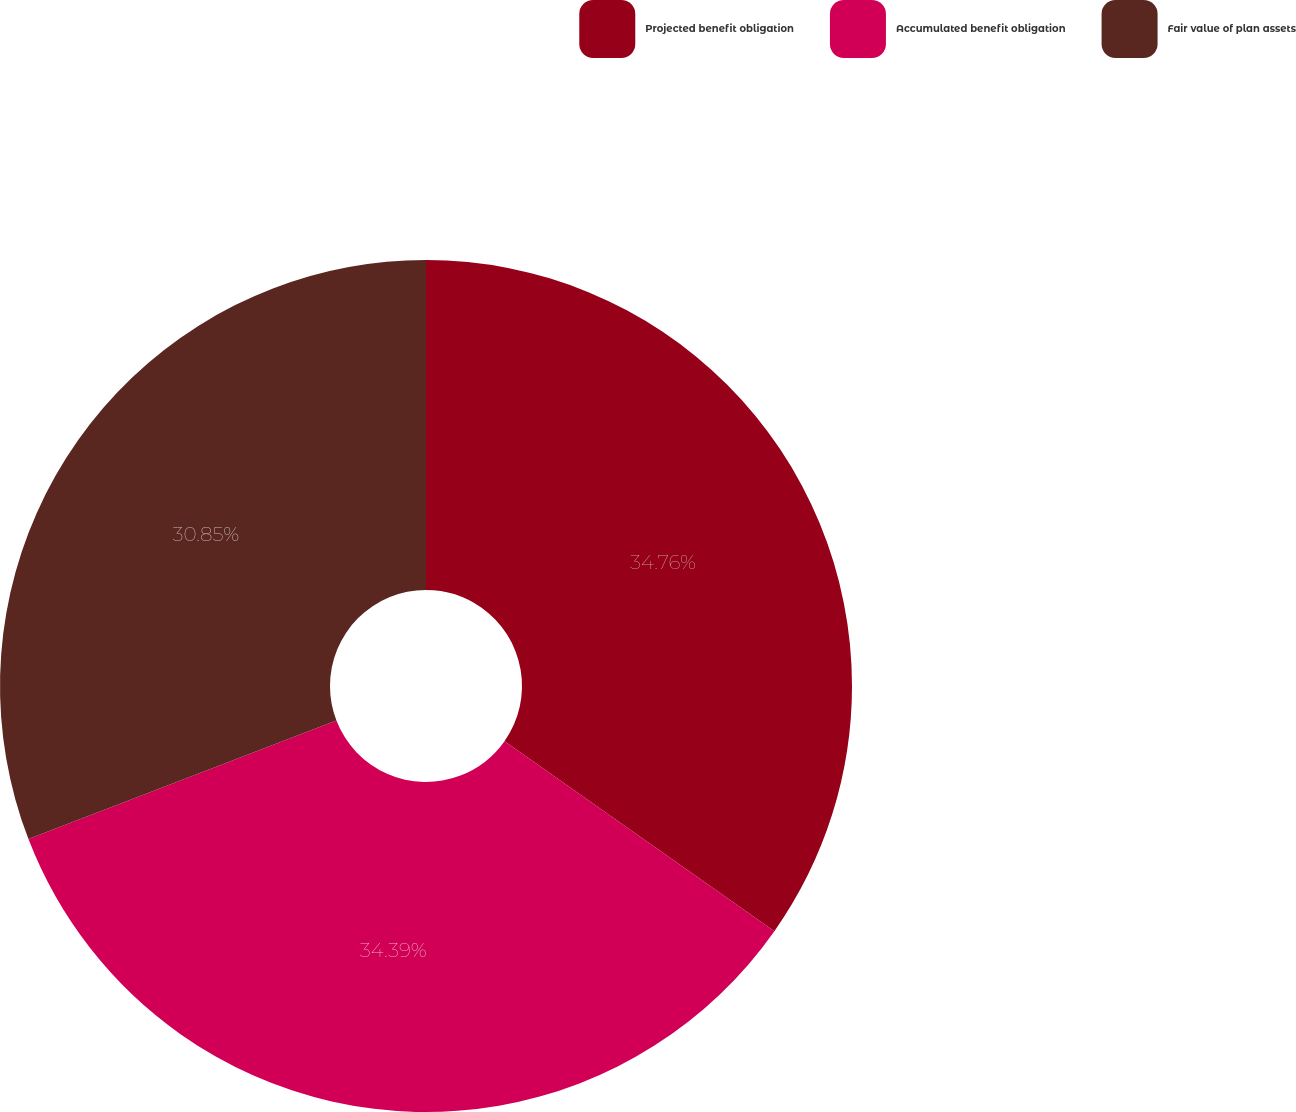<chart> <loc_0><loc_0><loc_500><loc_500><pie_chart><fcel>Projected benefit obligation<fcel>Accumulated benefit obligation<fcel>Fair value of plan assets<nl><fcel>34.76%<fcel>34.39%<fcel>30.85%<nl></chart> 